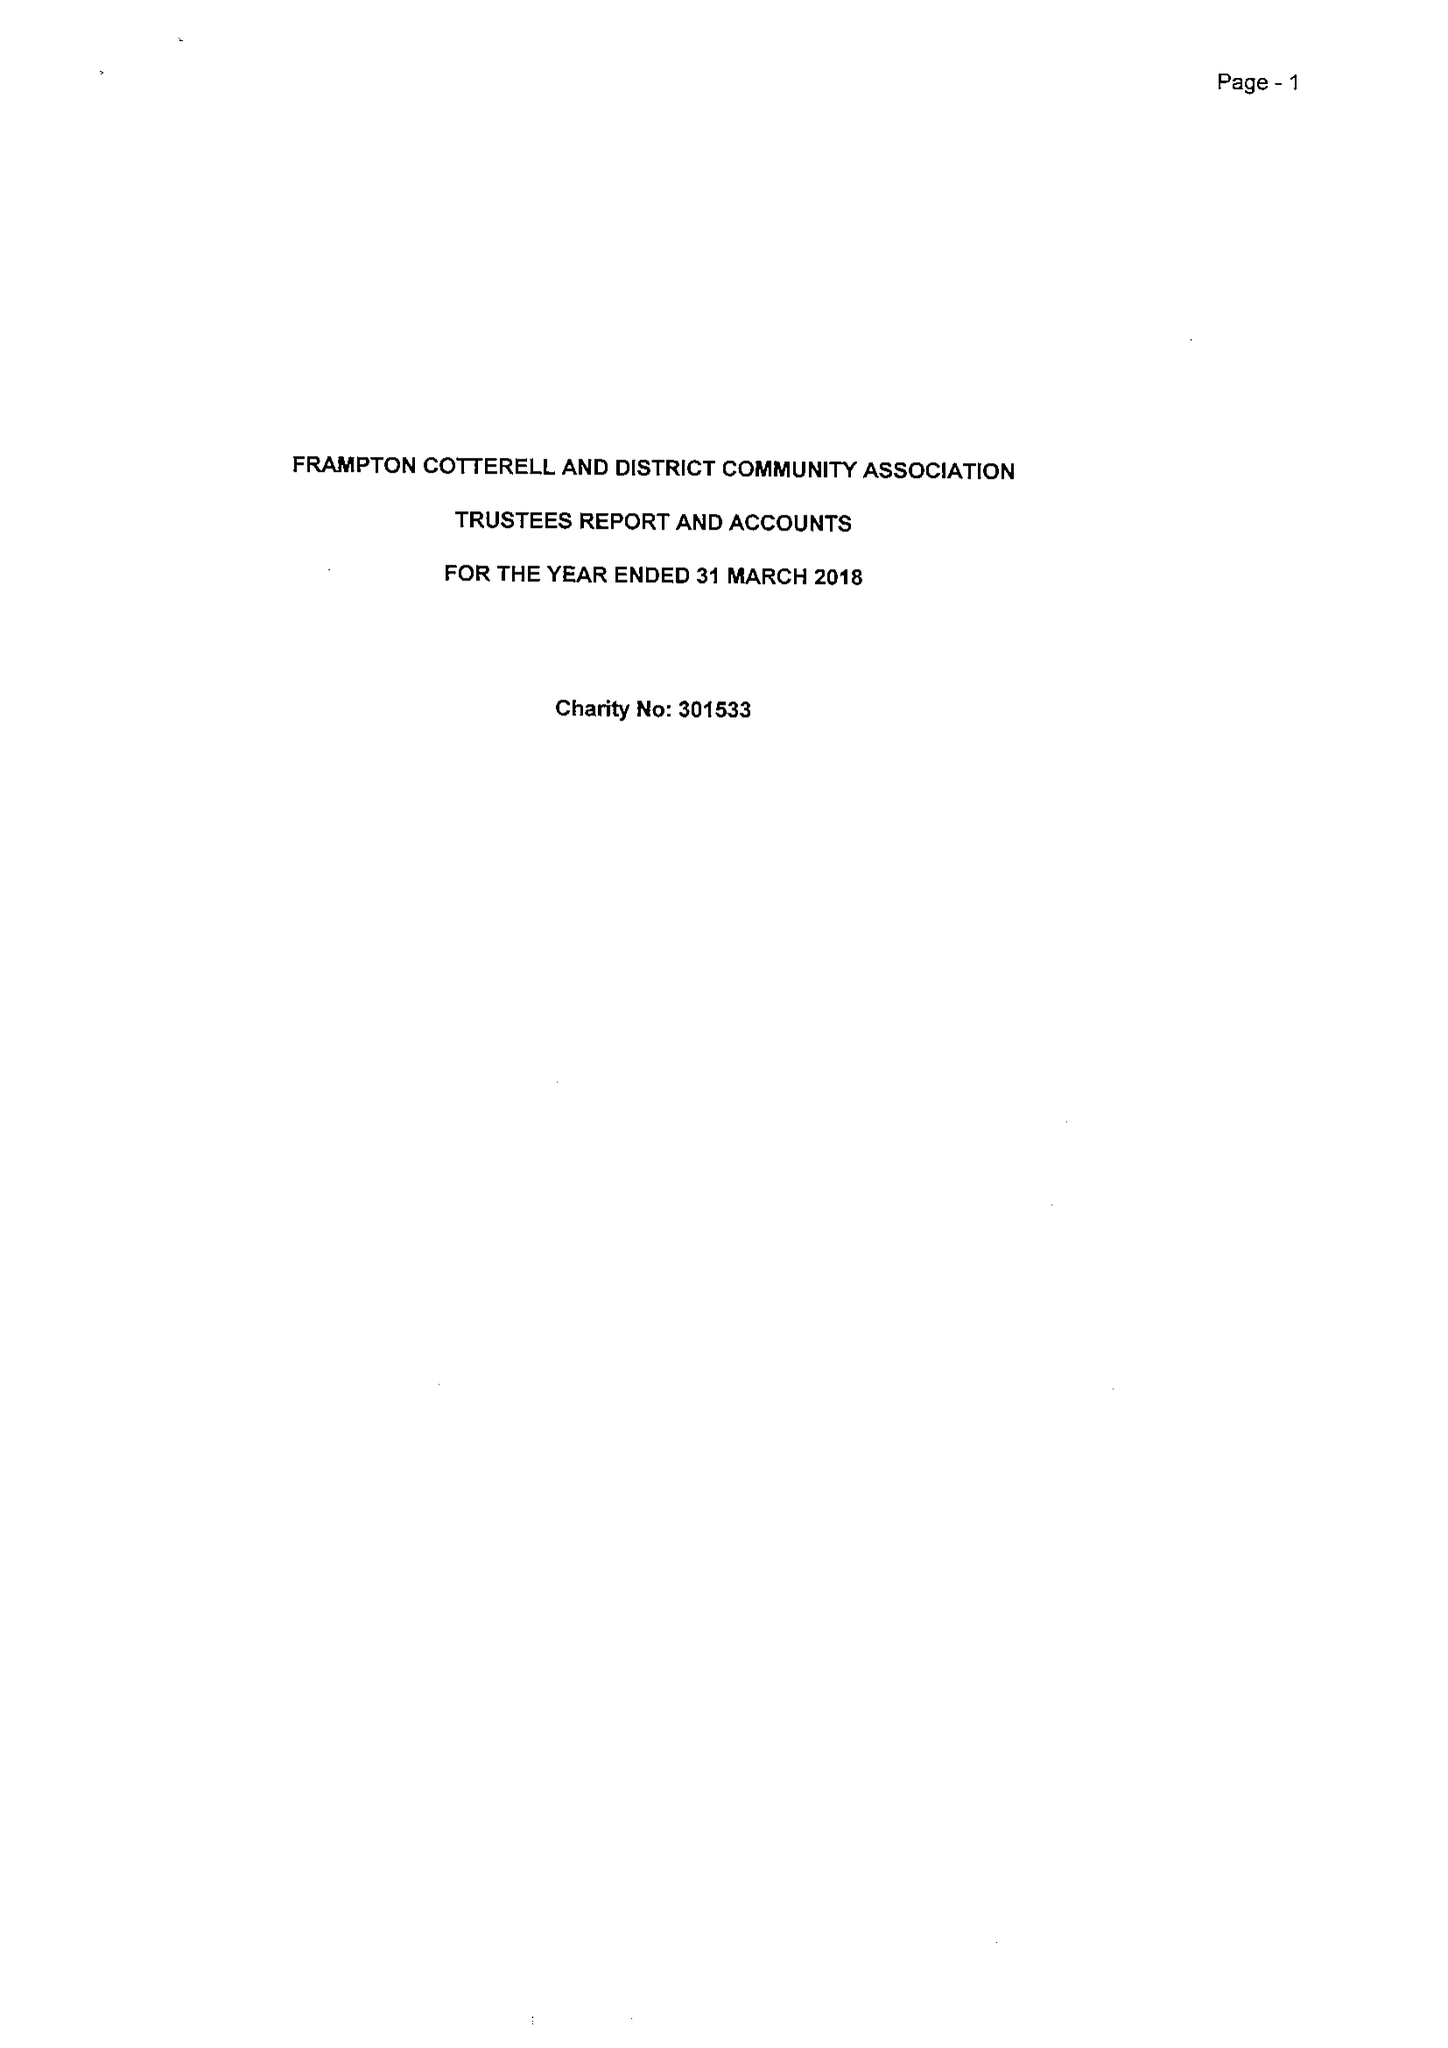What is the value for the income_annually_in_british_pounds?
Answer the question using a single word or phrase. 30535.00 